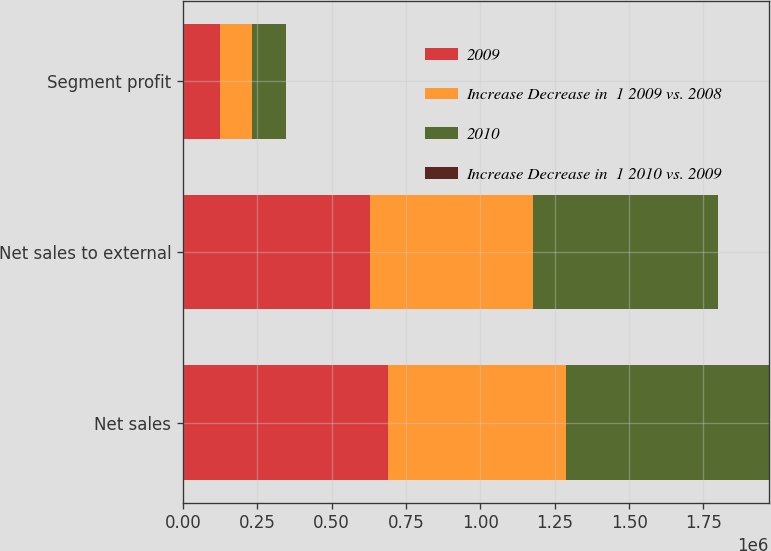Convert chart to OTSL. <chart><loc_0><loc_0><loc_500><loc_500><stacked_bar_chart><ecel><fcel>Net sales<fcel>Net sales to external<fcel>Segment profit<nl><fcel>2009<fcel>689546<fcel>628699<fcel>123384<nl><fcel>Increase Decrease in  1 2009 vs. 2008<fcel>597172<fcel>548677<fcel>107719<nl><fcel>2010<fcel>682282<fcel>622692<fcel>113578<nl><fcel>Increase Decrease in  1 2010 vs. 2009<fcel>15<fcel>15<fcel>15<nl></chart> 